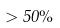<formula> <loc_0><loc_0><loc_500><loc_500>> 5 0 \%</formula> 